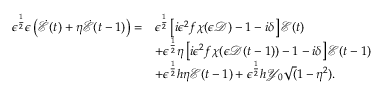<formula> <loc_0><loc_0><loc_500><loc_500>\begin{array} { r l } { \epsilon ^ { \frac { 1 } { 2 } } \epsilon \left ( \dot { \mathcal { E } } ( t ) + \eta \dot { \mathcal { E } } ( t - 1 ) \right ) = } & { \epsilon ^ { \frac { 1 } { 2 } } \left [ i \epsilon ^ { 2 } f \chi ( \epsilon \mathcal { D } ) - 1 - i \delta \right ] \mathcal { E } ( t ) } \\ & { + \epsilon ^ { \frac { 1 } { 2 } } \eta \left [ i \epsilon ^ { 2 } f \chi ( \epsilon \mathcal { D } ( t - 1 ) ) - 1 - i \delta \right ] \mathcal { E } ( t - 1 ) } \\ & { + \epsilon ^ { \frac { 1 } { 2 } } h \eta \mathcal { E } ( t - 1 ) + \epsilon ^ { \frac { 1 } { 2 } } h \mathcal { Y } _ { 0 } \sqrt { ( } 1 - \eta ^ { 2 } ) . } \end{array}</formula> 